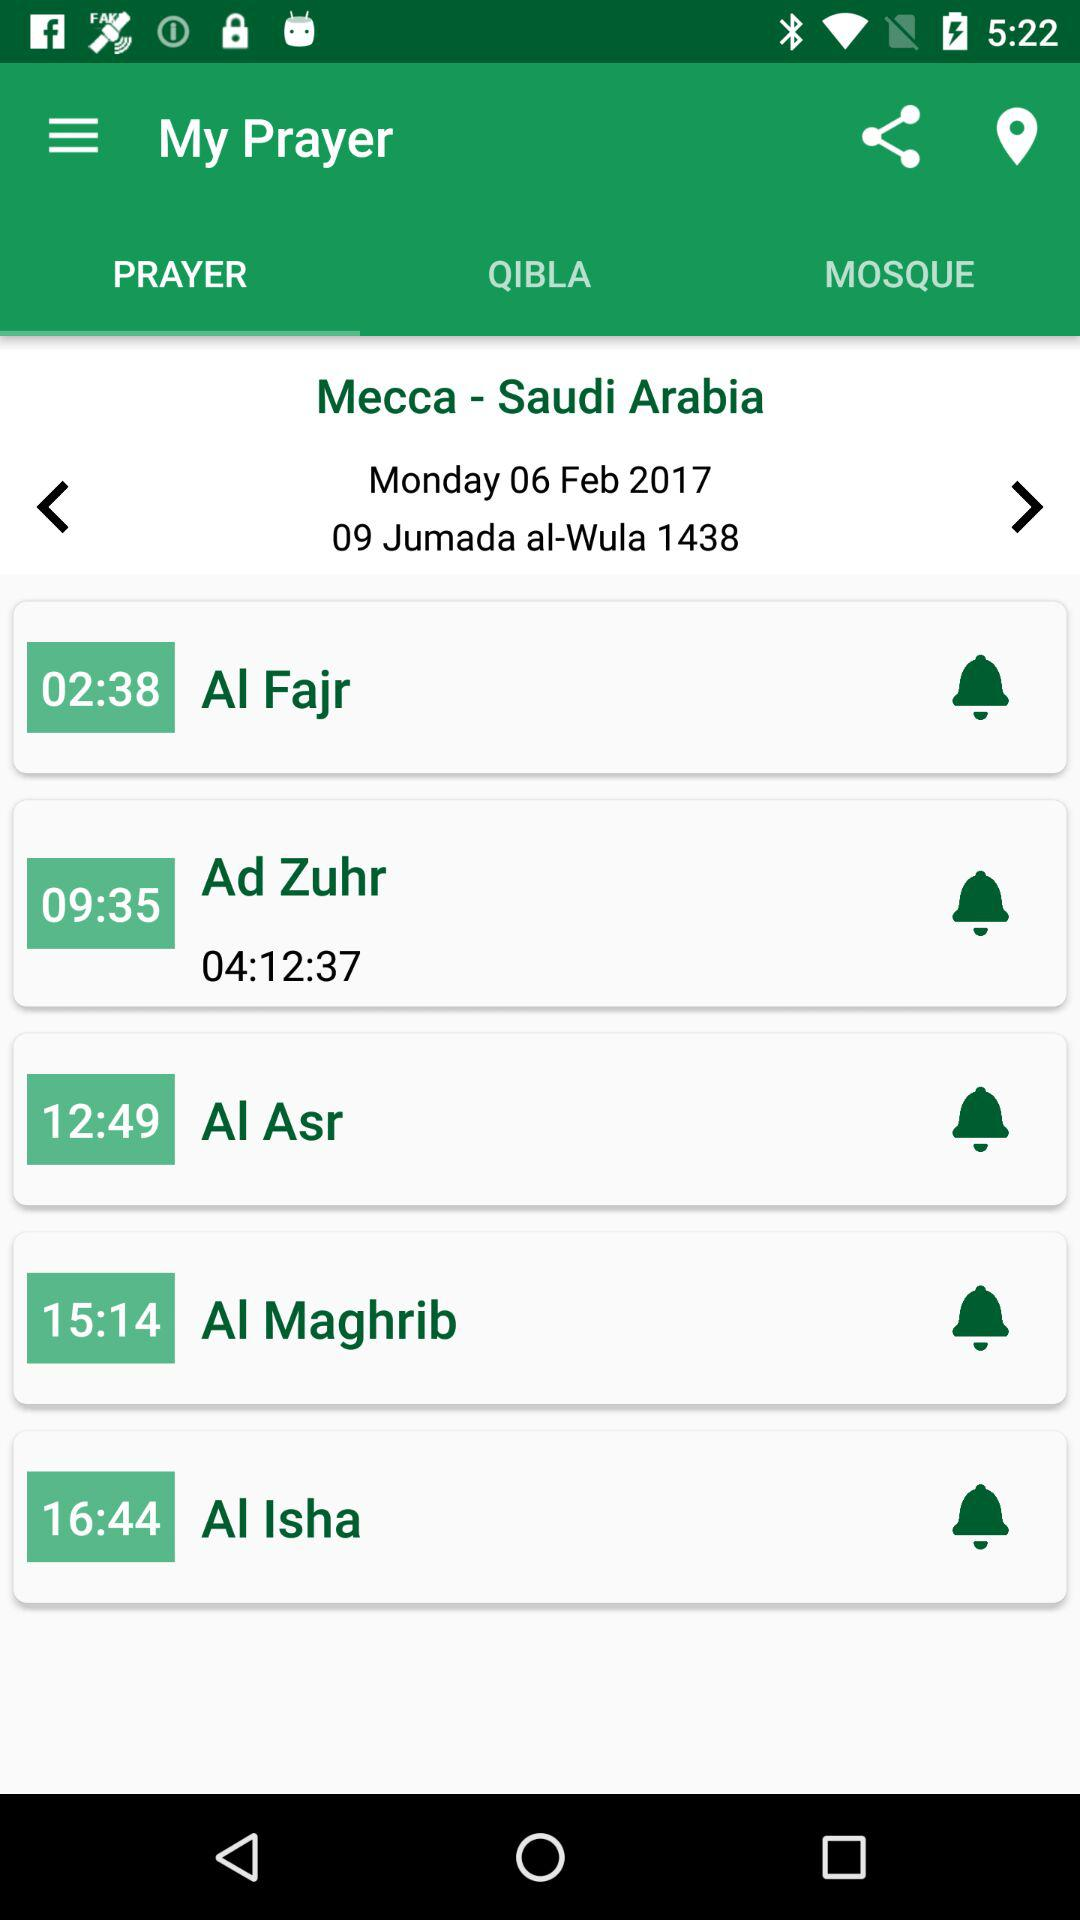At what time will we pray "Al Maghrib"? You will pray "Al Maghrib" at 15:14. 